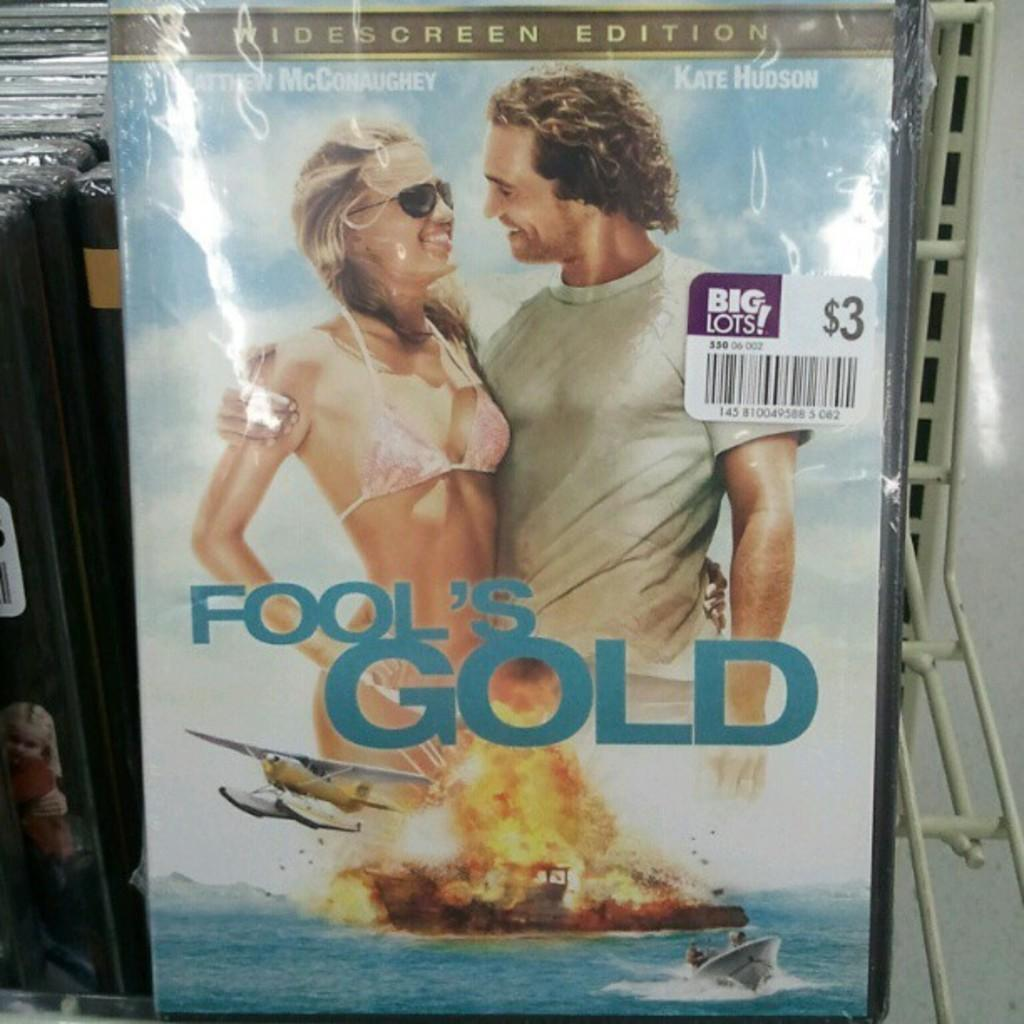<image>
Present a compact description of the photo's key features. A copy of Fool's Gold is only $3 at Big Lots. 